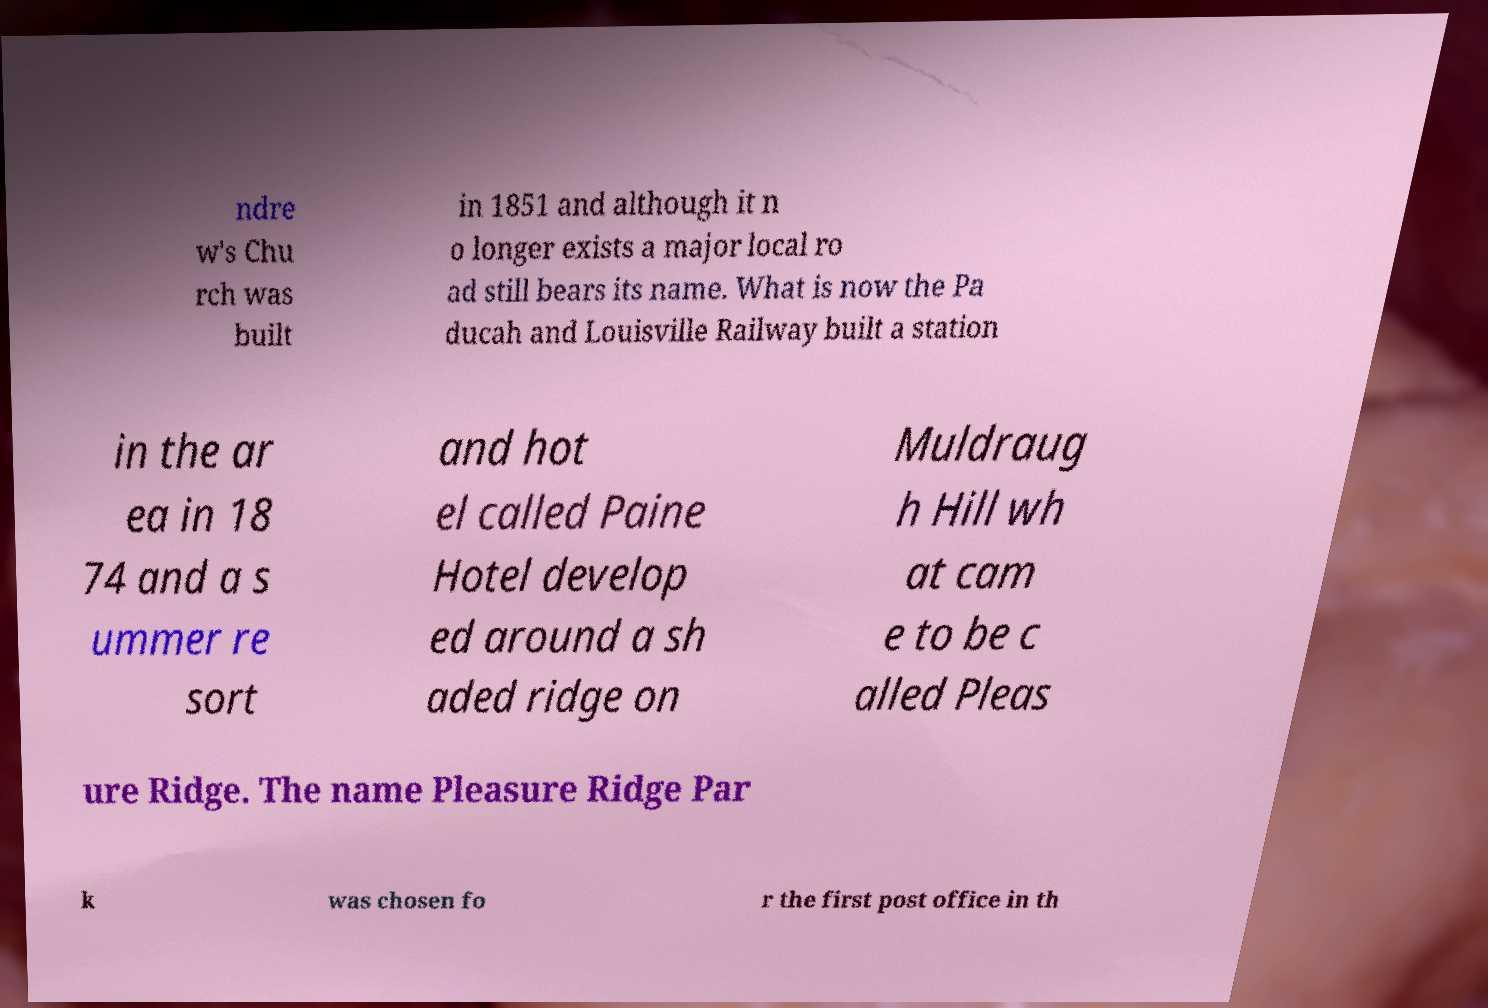Please read and relay the text visible in this image. What does it say? ndre w's Chu rch was built in 1851 and although it n o longer exists a major local ro ad still bears its name. What is now the Pa ducah and Louisville Railway built a station in the ar ea in 18 74 and a s ummer re sort and hot el called Paine Hotel develop ed around a sh aded ridge on Muldraug h Hill wh at cam e to be c alled Pleas ure Ridge. The name Pleasure Ridge Par k was chosen fo r the first post office in th 